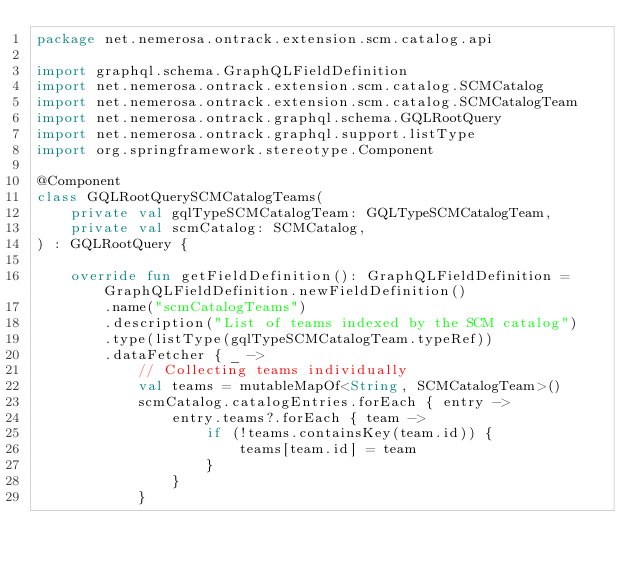Convert code to text. <code><loc_0><loc_0><loc_500><loc_500><_Kotlin_>package net.nemerosa.ontrack.extension.scm.catalog.api

import graphql.schema.GraphQLFieldDefinition
import net.nemerosa.ontrack.extension.scm.catalog.SCMCatalog
import net.nemerosa.ontrack.extension.scm.catalog.SCMCatalogTeam
import net.nemerosa.ontrack.graphql.schema.GQLRootQuery
import net.nemerosa.ontrack.graphql.support.listType
import org.springframework.stereotype.Component

@Component
class GQLRootQuerySCMCatalogTeams(
    private val gqlTypeSCMCatalogTeam: GQLTypeSCMCatalogTeam,
    private val scmCatalog: SCMCatalog,
) : GQLRootQuery {

    override fun getFieldDefinition(): GraphQLFieldDefinition = GraphQLFieldDefinition.newFieldDefinition()
        .name("scmCatalogTeams")
        .description("List of teams indexed by the SCM catalog")
        .type(listType(gqlTypeSCMCatalogTeam.typeRef))
        .dataFetcher { _ ->
            // Collecting teams individually
            val teams = mutableMapOf<String, SCMCatalogTeam>()
            scmCatalog.catalogEntries.forEach { entry ->
                entry.teams?.forEach { team ->
                    if (!teams.containsKey(team.id)) {
                        teams[team.id] = team
                    }
                }
            }</code> 